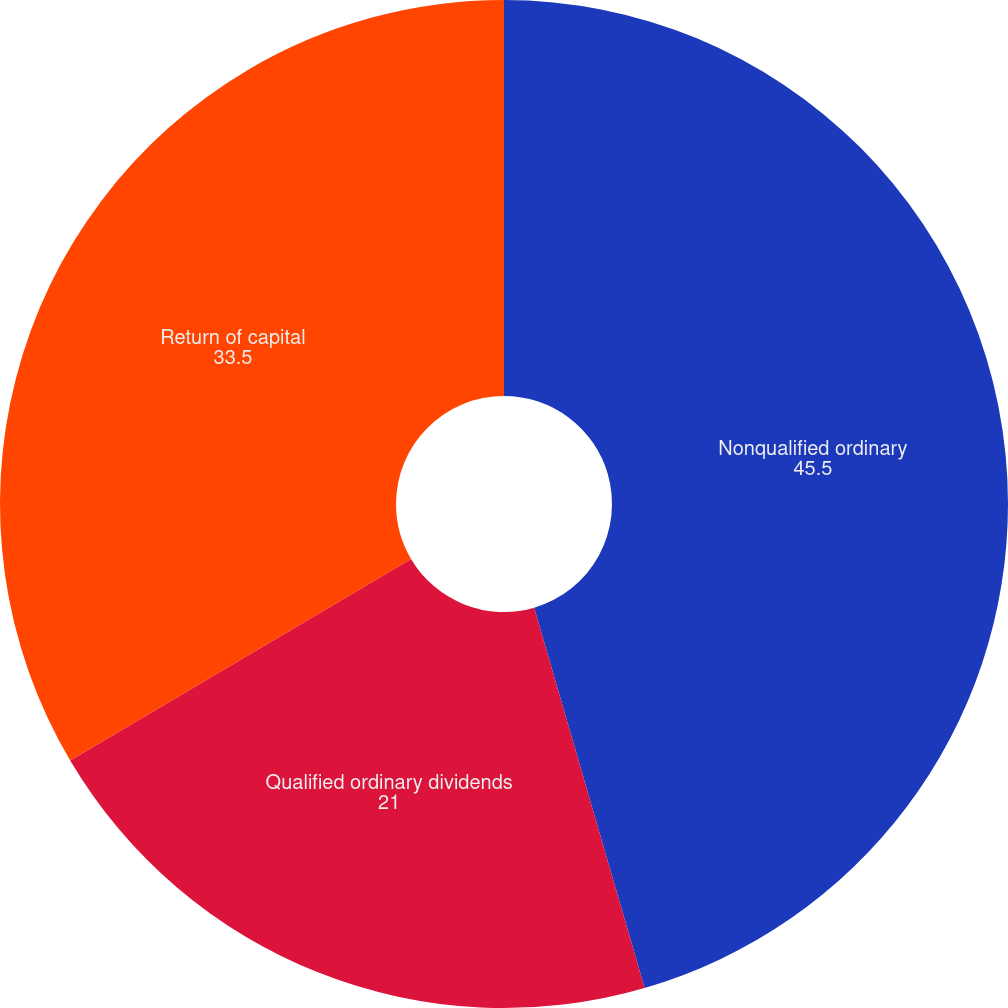<chart> <loc_0><loc_0><loc_500><loc_500><pie_chart><fcel>Nonqualified ordinary<fcel>Qualified ordinary dividends<fcel>Return of capital<nl><fcel>45.5%<fcel>21.0%<fcel>33.5%<nl></chart> 